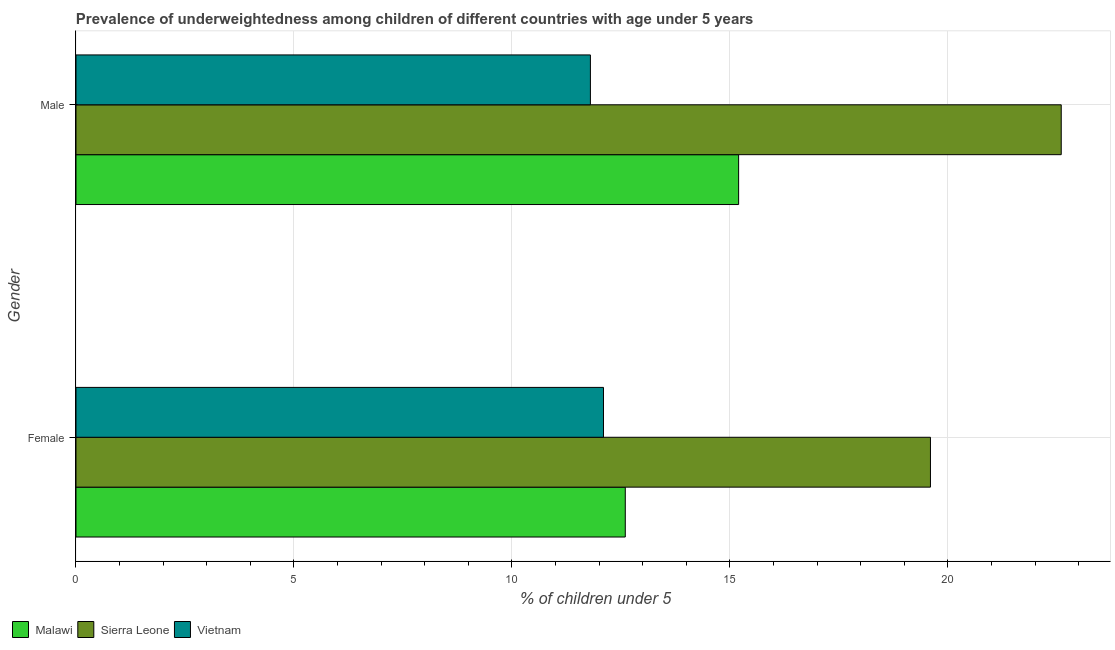How many groups of bars are there?
Provide a short and direct response. 2. Are the number of bars on each tick of the Y-axis equal?
Ensure brevity in your answer.  Yes. How many bars are there on the 2nd tick from the top?
Make the answer very short. 3. What is the percentage of underweighted male children in Sierra Leone?
Ensure brevity in your answer.  22.6. Across all countries, what is the maximum percentage of underweighted male children?
Ensure brevity in your answer.  22.6. Across all countries, what is the minimum percentage of underweighted male children?
Provide a short and direct response. 11.8. In which country was the percentage of underweighted female children maximum?
Your response must be concise. Sierra Leone. In which country was the percentage of underweighted female children minimum?
Keep it short and to the point. Vietnam. What is the total percentage of underweighted female children in the graph?
Provide a succinct answer. 44.3. What is the difference between the percentage of underweighted male children in Malawi and that in Sierra Leone?
Give a very brief answer. -7.4. What is the difference between the percentage of underweighted male children in Malawi and the percentage of underweighted female children in Vietnam?
Give a very brief answer. 3.1. What is the average percentage of underweighted male children per country?
Your answer should be compact. 16.53. What is the difference between the percentage of underweighted male children and percentage of underweighted female children in Malawi?
Your answer should be very brief. 2.6. In how many countries, is the percentage of underweighted male children greater than 20 %?
Provide a succinct answer. 1. What is the ratio of the percentage of underweighted male children in Sierra Leone to that in Malawi?
Make the answer very short. 1.49. Is the percentage of underweighted female children in Sierra Leone less than that in Vietnam?
Your response must be concise. No. What does the 2nd bar from the top in Female represents?
Your answer should be very brief. Sierra Leone. What does the 3rd bar from the bottom in Female represents?
Your answer should be compact. Vietnam. How many bars are there?
Your response must be concise. 6. Are all the bars in the graph horizontal?
Offer a very short reply. Yes. What is the difference between two consecutive major ticks on the X-axis?
Your answer should be compact. 5. Are the values on the major ticks of X-axis written in scientific E-notation?
Give a very brief answer. No. Does the graph contain any zero values?
Your response must be concise. No. Where does the legend appear in the graph?
Keep it short and to the point. Bottom left. How many legend labels are there?
Your answer should be compact. 3. How are the legend labels stacked?
Offer a very short reply. Horizontal. What is the title of the graph?
Provide a succinct answer. Prevalence of underweightedness among children of different countries with age under 5 years. Does "Senegal" appear as one of the legend labels in the graph?
Offer a terse response. No. What is the label or title of the X-axis?
Make the answer very short.  % of children under 5. What is the  % of children under 5 of Malawi in Female?
Make the answer very short. 12.6. What is the  % of children under 5 in Sierra Leone in Female?
Your answer should be compact. 19.6. What is the  % of children under 5 of Vietnam in Female?
Provide a succinct answer. 12.1. What is the  % of children under 5 in Malawi in Male?
Provide a succinct answer. 15.2. What is the  % of children under 5 of Sierra Leone in Male?
Give a very brief answer. 22.6. What is the  % of children under 5 in Vietnam in Male?
Make the answer very short. 11.8. Across all Gender, what is the maximum  % of children under 5 of Malawi?
Your response must be concise. 15.2. Across all Gender, what is the maximum  % of children under 5 of Sierra Leone?
Your answer should be very brief. 22.6. Across all Gender, what is the maximum  % of children under 5 of Vietnam?
Offer a very short reply. 12.1. Across all Gender, what is the minimum  % of children under 5 in Malawi?
Offer a terse response. 12.6. Across all Gender, what is the minimum  % of children under 5 of Sierra Leone?
Offer a very short reply. 19.6. Across all Gender, what is the minimum  % of children under 5 in Vietnam?
Offer a terse response. 11.8. What is the total  % of children under 5 of Malawi in the graph?
Ensure brevity in your answer.  27.8. What is the total  % of children under 5 of Sierra Leone in the graph?
Your response must be concise. 42.2. What is the total  % of children under 5 of Vietnam in the graph?
Your response must be concise. 23.9. What is the difference between the  % of children under 5 of Malawi in Female and that in Male?
Keep it short and to the point. -2.6. What is the difference between the  % of children under 5 in Sierra Leone in Female and that in Male?
Offer a very short reply. -3. What is the difference between the  % of children under 5 of Vietnam in Female and that in Male?
Offer a terse response. 0.3. What is the difference between the  % of children under 5 in Malawi in Female and the  % of children under 5 in Vietnam in Male?
Offer a terse response. 0.8. What is the difference between the  % of children under 5 of Sierra Leone in Female and the  % of children under 5 of Vietnam in Male?
Provide a succinct answer. 7.8. What is the average  % of children under 5 in Sierra Leone per Gender?
Your answer should be very brief. 21.1. What is the average  % of children under 5 of Vietnam per Gender?
Make the answer very short. 11.95. What is the difference between the  % of children under 5 in Sierra Leone and  % of children under 5 in Vietnam in Female?
Your answer should be very brief. 7.5. What is the difference between the  % of children under 5 in Malawi and  % of children under 5 in Vietnam in Male?
Keep it short and to the point. 3.4. What is the difference between the  % of children under 5 of Sierra Leone and  % of children under 5 of Vietnam in Male?
Your answer should be compact. 10.8. What is the ratio of the  % of children under 5 of Malawi in Female to that in Male?
Your answer should be very brief. 0.83. What is the ratio of the  % of children under 5 in Sierra Leone in Female to that in Male?
Your answer should be very brief. 0.87. What is the ratio of the  % of children under 5 in Vietnam in Female to that in Male?
Your answer should be compact. 1.03. What is the difference between the highest and the second highest  % of children under 5 of Malawi?
Your answer should be compact. 2.6. What is the difference between the highest and the second highest  % of children under 5 in Sierra Leone?
Keep it short and to the point. 3. What is the difference between the highest and the second highest  % of children under 5 in Vietnam?
Make the answer very short. 0.3. What is the difference between the highest and the lowest  % of children under 5 of Vietnam?
Make the answer very short. 0.3. 